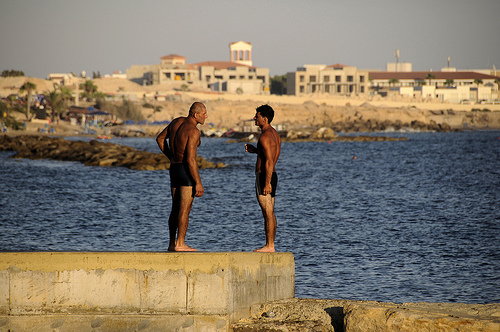<image>
Is there a man on the concrete? Yes. Looking at the image, I can see the man is positioned on top of the concrete, with the concrete providing support. 